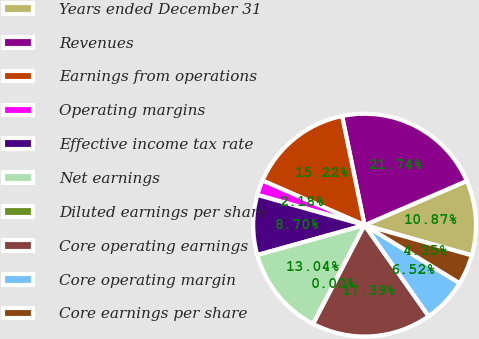<chart> <loc_0><loc_0><loc_500><loc_500><pie_chart><fcel>Years ended December 31<fcel>Revenues<fcel>Earnings from operations<fcel>Operating margins<fcel>Effective income tax rate<fcel>Net earnings<fcel>Diluted earnings per share<fcel>Core operating earnings<fcel>Core operating margin<fcel>Core earnings per share<nl><fcel>10.87%<fcel>21.74%<fcel>15.22%<fcel>2.18%<fcel>8.7%<fcel>13.04%<fcel>0.0%<fcel>17.39%<fcel>6.52%<fcel>4.35%<nl></chart> 